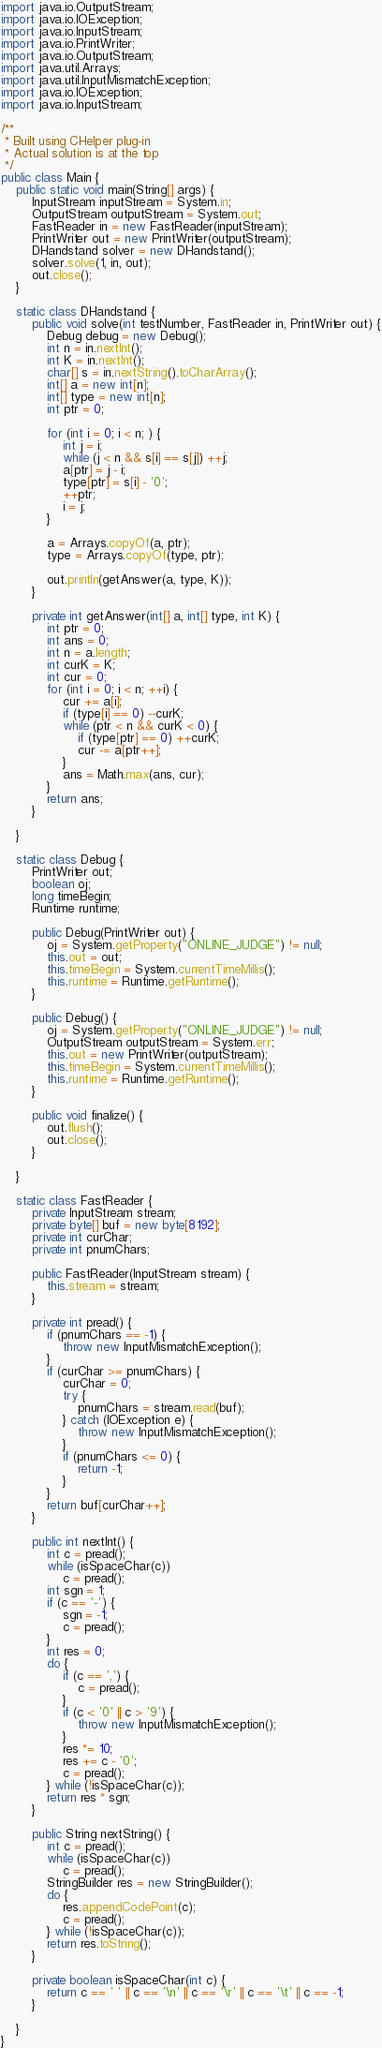<code> <loc_0><loc_0><loc_500><loc_500><_Java_>import java.io.OutputStream;
import java.io.IOException;
import java.io.InputStream;
import java.io.PrintWriter;
import java.io.OutputStream;
import java.util.Arrays;
import java.util.InputMismatchException;
import java.io.IOException;
import java.io.InputStream;

/**
 * Built using CHelper plug-in
 * Actual solution is at the top
 */
public class Main {
    public static void main(String[] args) {
        InputStream inputStream = System.in;
        OutputStream outputStream = System.out;
        FastReader in = new FastReader(inputStream);
        PrintWriter out = new PrintWriter(outputStream);
        DHandstand solver = new DHandstand();
        solver.solve(1, in, out);
        out.close();
    }

    static class DHandstand {
        public void solve(int testNumber, FastReader in, PrintWriter out) {
            Debug debug = new Debug();
            int n = in.nextInt();
            int K = in.nextInt();
            char[] s = in.nextString().toCharArray();
            int[] a = new int[n];
            int[] type = new int[n];
            int ptr = 0;

            for (int i = 0; i < n; ) {
                int j = i;
                while (j < n && s[i] == s[j]) ++j;
                a[ptr] = j - i;
                type[ptr] = s[i] - '0';
                ++ptr;
                i = j;
            }

            a = Arrays.copyOf(a, ptr);
            type = Arrays.copyOf(type, ptr);

            out.println(getAnswer(a, type, K));
        }

        private int getAnswer(int[] a, int[] type, int K) {
            int ptr = 0;
            int ans = 0;
            int n = a.length;
            int curK = K;
            int cur = 0;
            for (int i = 0; i < n; ++i) {
                cur += a[i];
                if (type[i] == 0) --curK;
                while (ptr < n && curK < 0) {
                    if (type[ptr] == 0) ++curK;
                    cur -= a[ptr++];
                }
                ans = Math.max(ans, cur);
            }
            return ans;
        }

    }

    static class Debug {
        PrintWriter out;
        boolean oj;
        long timeBegin;
        Runtime runtime;

        public Debug(PrintWriter out) {
            oj = System.getProperty("ONLINE_JUDGE") != null;
            this.out = out;
            this.timeBegin = System.currentTimeMillis();
            this.runtime = Runtime.getRuntime();
        }

        public Debug() {
            oj = System.getProperty("ONLINE_JUDGE") != null;
            OutputStream outputStream = System.err;
            this.out = new PrintWriter(outputStream);
            this.timeBegin = System.currentTimeMillis();
            this.runtime = Runtime.getRuntime();
        }

        public void finalize() {
            out.flush();
            out.close();
        }

    }

    static class FastReader {
        private InputStream stream;
        private byte[] buf = new byte[8192];
        private int curChar;
        private int pnumChars;

        public FastReader(InputStream stream) {
            this.stream = stream;
        }

        private int pread() {
            if (pnumChars == -1) {
                throw new InputMismatchException();
            }
            if (curChar >= pnumChars) {
                curChar = 0;
                try {
                    pnumChars = stream.read(buf);
                } catch (IOException e) {
                    throw new InputMismatchException();
                }
                if (pnumChars <= 0) {
                    return -1;
                }
            }
            return buf[curChar++];
        }

        public int nextInt() {
            int c = pread();
            while (isSpaceChar(c))
                c = pread();
            int sgn = 1;
            if (c == '-') {
                sgn = -1;
                c = pread();
            }
            int res = 0;
            do {
                if (c == ',') {
                    c = pread();
                }
                if (c < '0' || c > '9') {
                    throw new InputMismatchException();
                }
                res *= 10;
                res += c - '0';
                c = pread();
            } while (!isSpaceChar(c));
            return res * sgn;
        }

        public String nextString() {
            int c = pread();
            while (isSpaceChar(c))
                c = pread();
            StringBuilder res = new StringBuilder();
            do {
                res.appendCodePoint(c);
                c = pread();
            } while (!isSpaceChar(c));
            return res.toString();
        }

        private boolean isSpaceChar(int c) {
            return c == ' ' || c == '\n' || c == '\r' || c == '\t' || c == -1;
        }

    }
}

</code> 